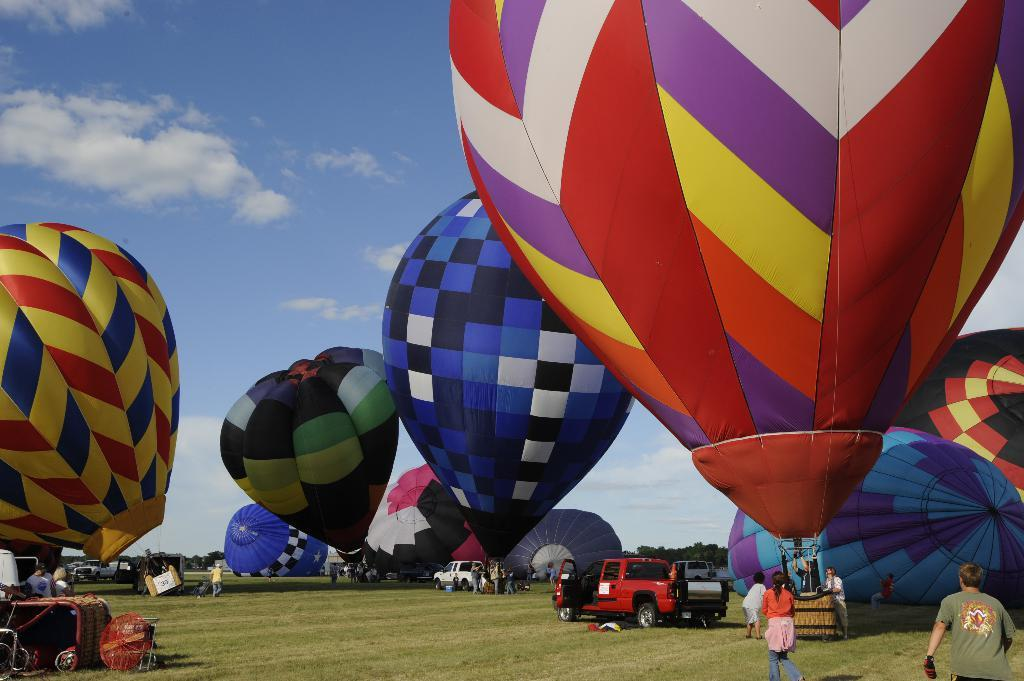What is the main object in the picture? There is a parachute in the picture. What colors can be seen on the parachute? The parachute has different colors, including red, blue, and yellow. How would you describe the sky in the picture? The sky is clear. Where is the seat located in the picture? There is no seat present in the image; it features a parachute in the sky. What type of shock can be seen on the parachute? There is no shock present on the parachute in the image. 